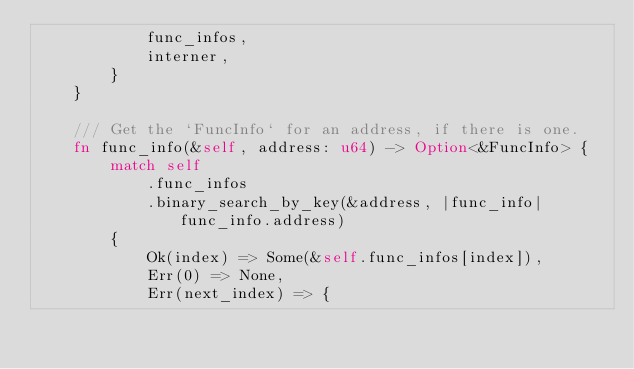<code> <loc_0><loc_0><loc_500><loc_500><_Rust_>            func_infos,
            interner,
        }
    }

    /// Get the `FuncInfo` for an address, if there is one.
    fn func_info(&self, address: u64) -> Option<&FuncInfo> {
        match self
            .func_infos
            .binary_search_by_key(&address, |func_info| func_info.address)
        {
            Ok(index) => Some(&self.func_infos[index]),
            Err(0) => None,
            Err(next_index) => {</code> 